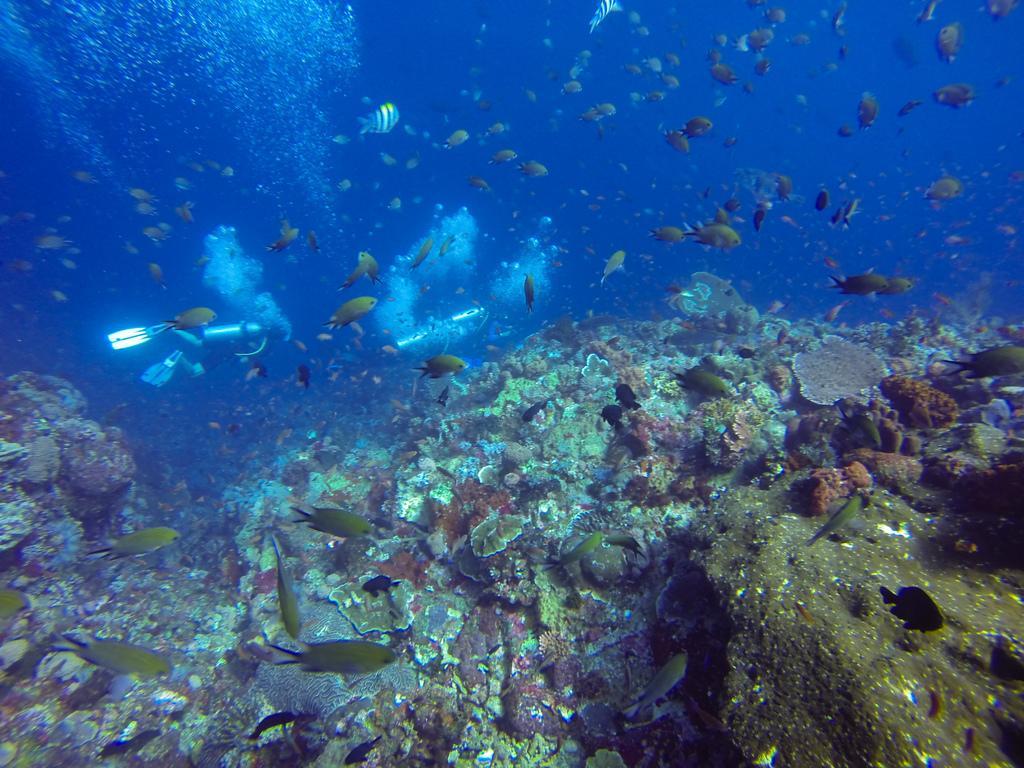In one or two sentences, can you explain what this image depicts? In this image, we can see some small fishes in the water. 